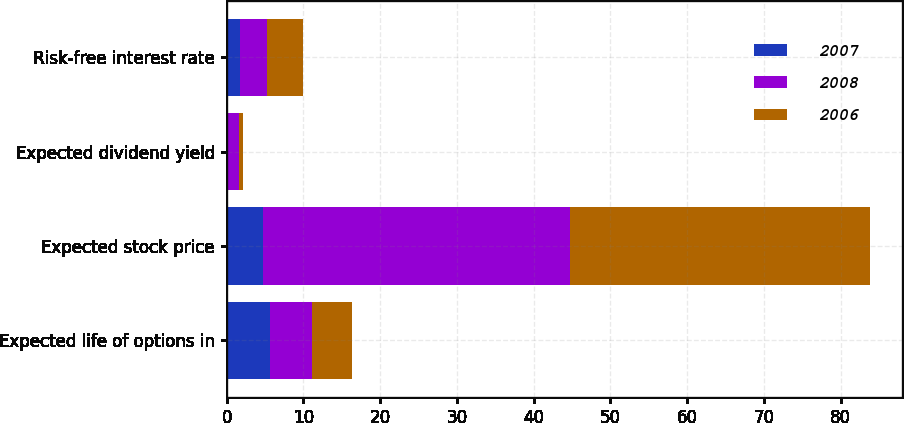Convert chart to OTSL. <chart><loc_0><loc_0><loc_500><loc_500><stacked_bar_chart><ecel><fcel>Expected life of options in<fcel>Expected stock price<fcel>Expected dividend yield<fcel>Risk-free interest rate<nl><fcel>2007<fcel>5.6<fcel>4.8<fcel>0.1<fcel>1.8<nl><fcel>2008<fcel>5.5<fcel>40<fcel>1.5<fcel>3.4<nl><fcel>2006<fcel>5.2<fcel>39<fcel>0.5<fcel>4.8<nl></chart> 